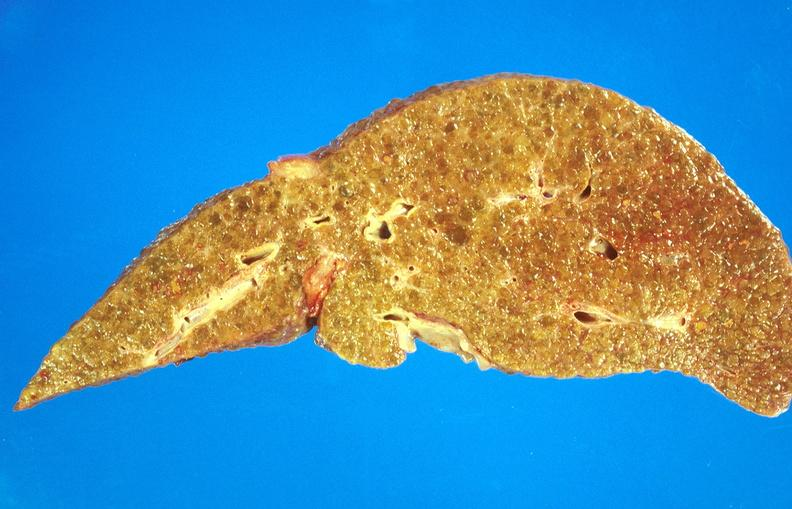s hepatobiliary present?
Answer the question using a single word or phrase. Yes 